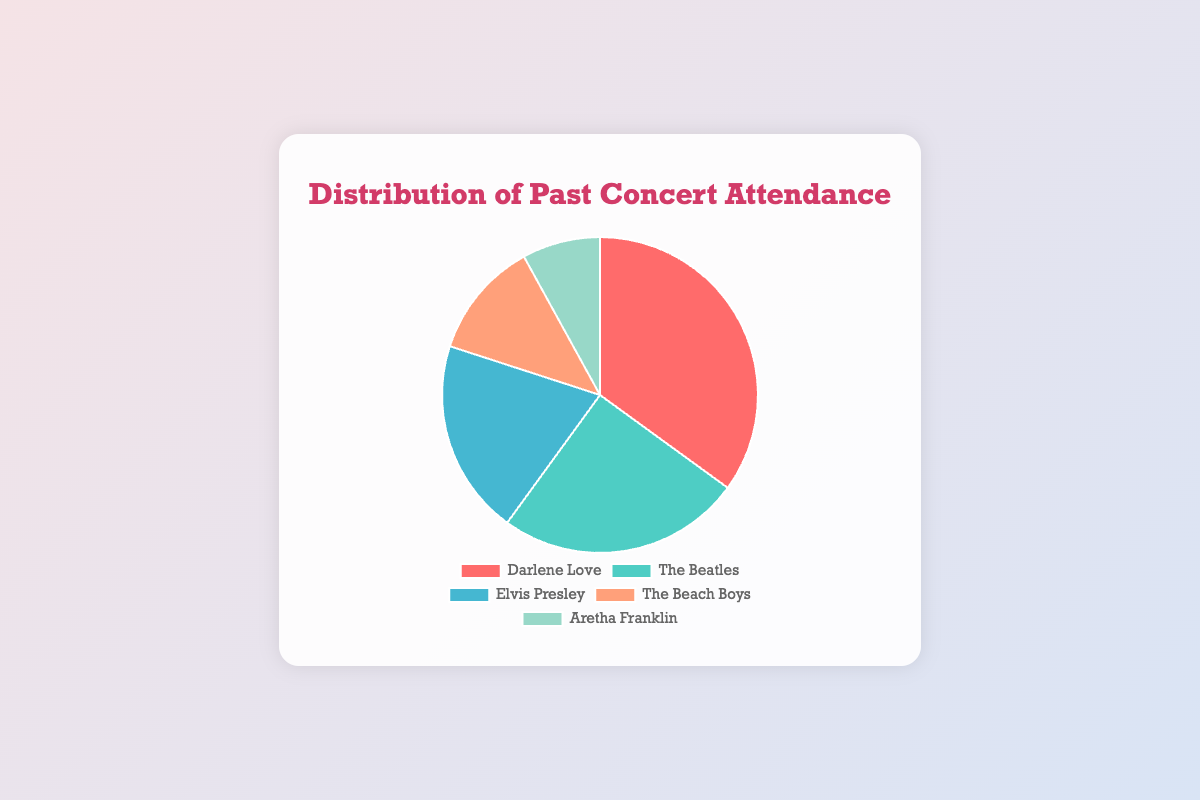What percentage of concert attendance is attributed to Darlene Love? The figure shows the distribution of past concert attendance by artist. Darlene Love accounts for 35% as indicated by the data segment.
Answer: 35% Which artist has the second highest concert attendance? By examining the pie chart, The Beatles have the second largest segment representing 25% of attendance, following Darlene Love who has the highest.
Answer: The Beatles How much more attendance does Darlene Love have compared to Aretha Franklin? Darlene Love's attendance is 35% and Aretha Franklin's is 8%. The difference is calculated as 35% - 8% = 27%.
Answer: 27% What is the total percentage attendance for The Beach Boys and Aretha Franklin combined? The attendance for The Beach Boys is 12% and for Aretha Franklin it is 8%. Adding them together gives 12% + 8% = 20%.
Answer: 20% Who has the least amount of concert attendance and what is the percentage? The smallest segment in the pie chart corresponds to Aretha Franklin with 8% attendance.
Answer: Aretha Franklin How many artists have an attendance percentage greater than 20%? By checking the segments and their percentages, both Darlene Love (35%) and The Beatles (25%) have attendance above 20%. That makes 2 artists.
Answer: 2 What is the difference in percentage points between The Beatles and Elvis Presley? The Beatles have an attendance percentage of 25% and Elvis Presley has 20%. The difference is 25% - 20% = 5%.
Answer: 5% If Darlene Love's attendance was reduced by 10%, what would her new percentage be? Reducing Darlene Love's attendance by 10% from 35% gives 35% - 10% = 25%.
Answer: 25% What percentage of concert attendance is attributed to the combined total of Darlene Love and Elvis Presley? Adding the attendance percentages for Darlene Love (35%) and Elvis Presley (20%) gives 35% + 20% = 55%.
Answer: 55% Which color is associated with The Beach Boys in the pie chart? The coloration of each segment can be seen visually, where The Beach Boys are represented by a light orange color.
Answer: Light Orange 